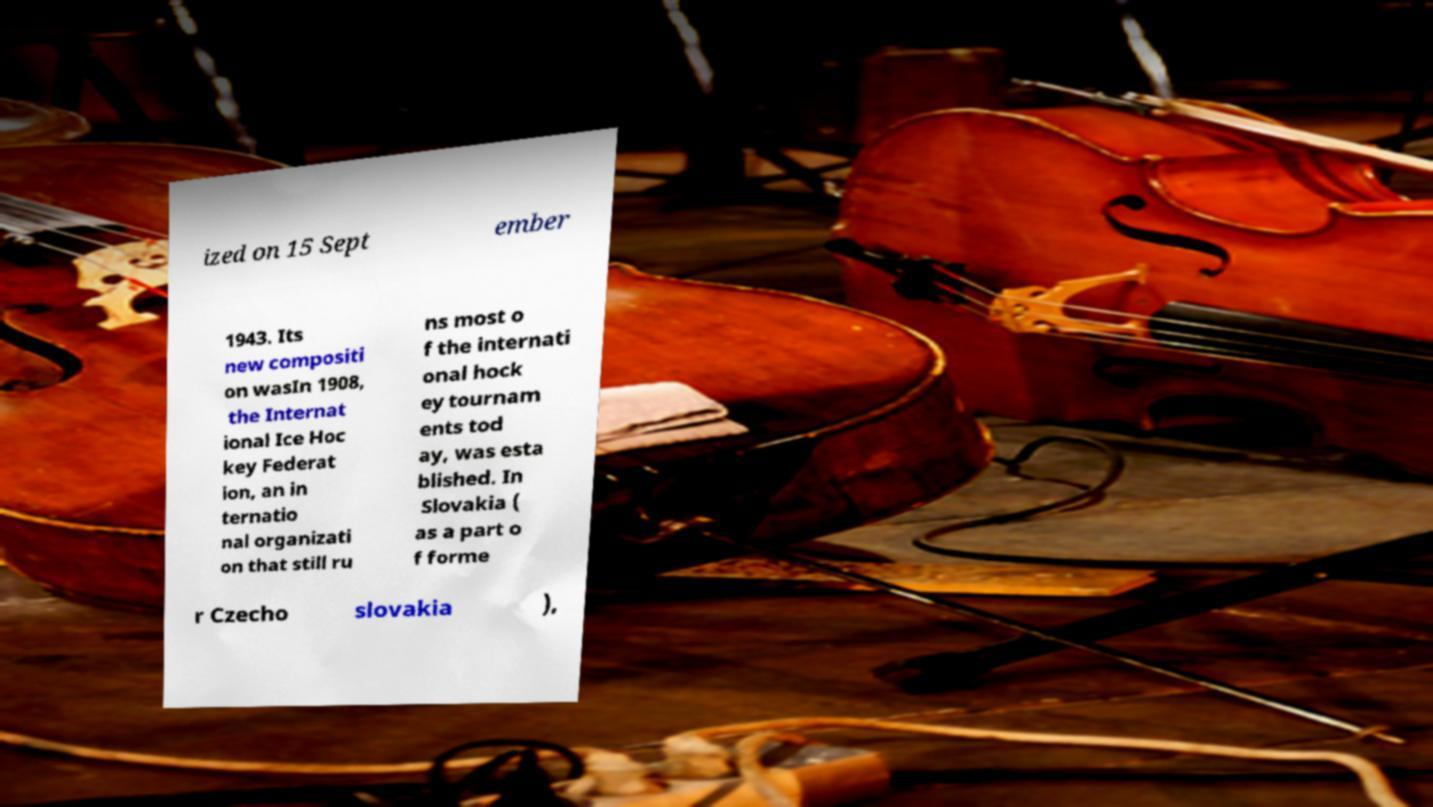Please identify and transcribe the text found in this image. ized on 15 Sept ember 1943. Its new compositi on wasIn 1908, the Internat ional Ice Hoc key Federat ion, an in ternatio nal organizati on that still ru ns most o f the internati onal hock ey tournam ents tod ay, was esta blished. In Slovakia ( as a part o f forme r Czecho slovakia ), 